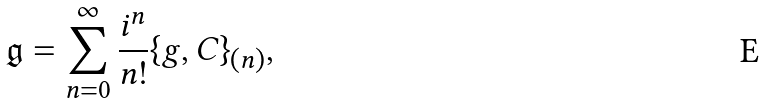<formula> <loc_0><loc_0><loc_500><loc_500>\mathfrak { g } = \sum _ { n = 0 } ^ { \infty } \frac { i ^ { n } } { n ! } \{ g , C \} _ { ( n ) } ,</formula> 